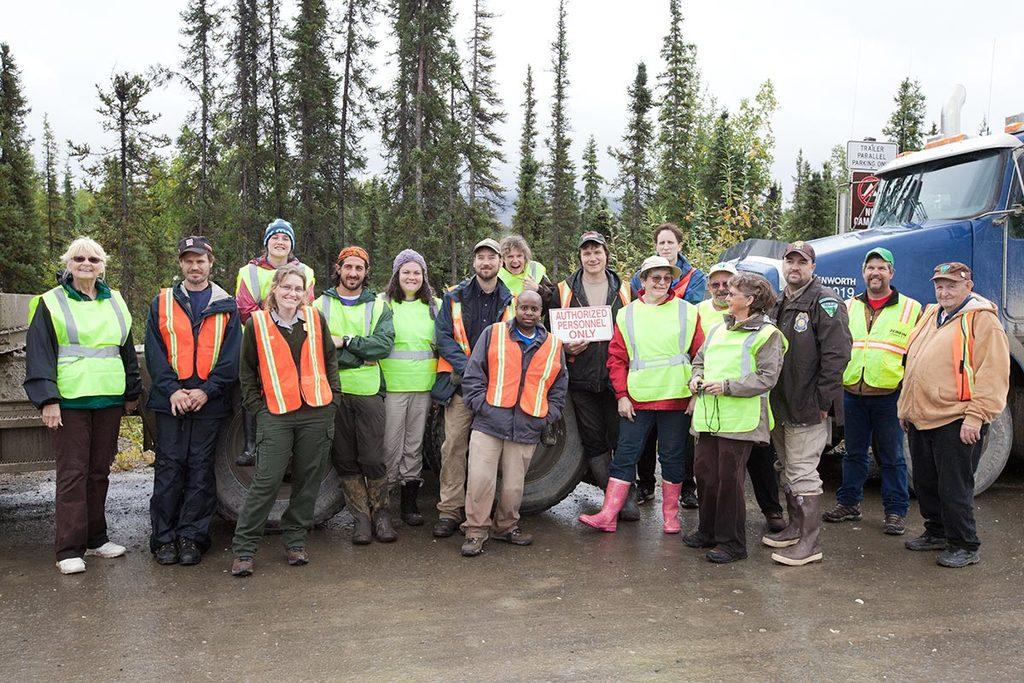What is happening in the image? There is a group of people standing in the image. What else can be seen in the image besides the people? There are vehicles on the road and trees in the image. What is visible in the background of the image? The sky is visible in the background of the image. How many cloths are hanging from the trees in the image? There are no cloths present in the image; it features a group of people, vehicles, trees, and the sky. Can you see a hen in the image? There is no hen present in the image. 